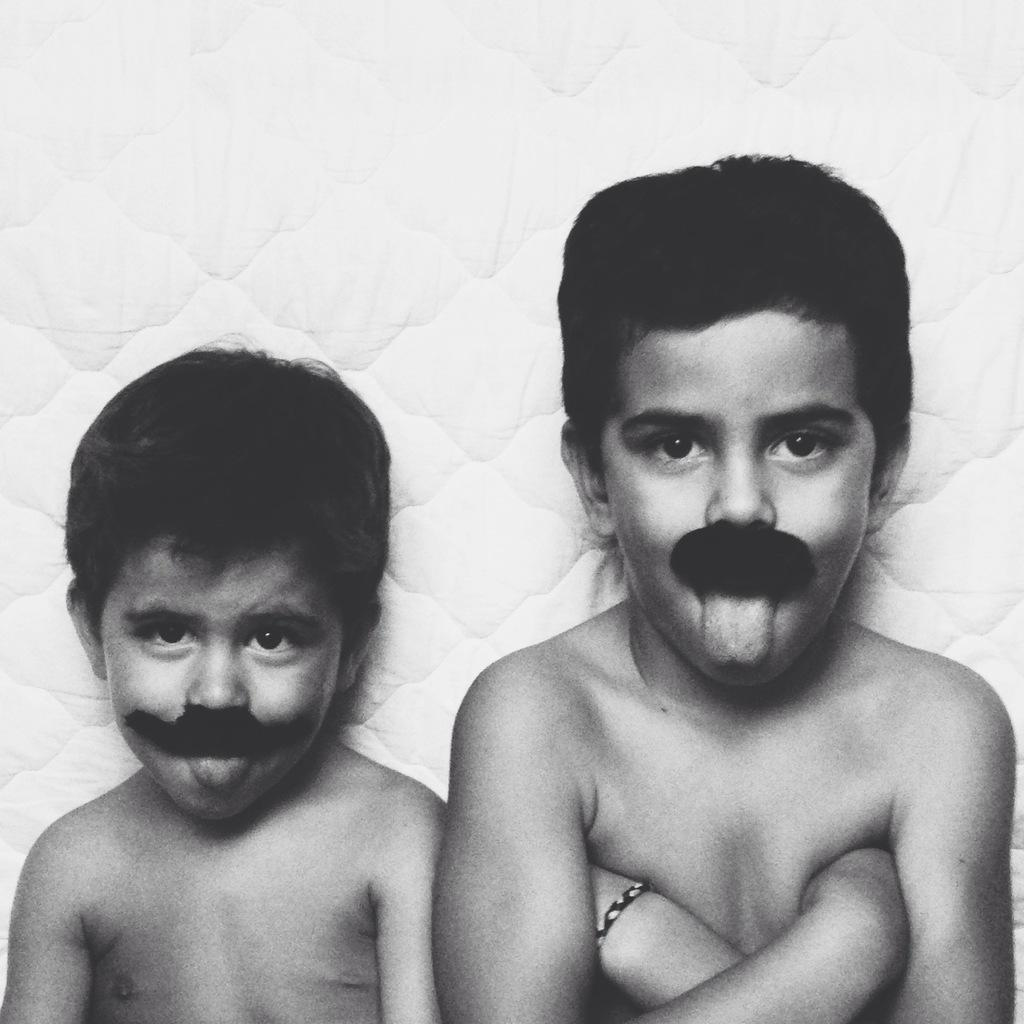How many children are present in the image? There are two small boys in the image. Where are the boys located in the image? The boys are in the center of the image. Reasoning: Let' Let's think step by step in order to produce the conversation. We start by identifying the main subjects in the image, which are the two small boys. Then, we describe their location within the image, noting that they are in the center. Each question is designed to elicit a specific detail about the image that is known from the provided facts. Absurd Question/Answer: What type of flower is the actor holding during the holiday scene in the image? There is no actor, flower, or holiday scene present in the image; it features two small boys in the center. What type of flower is the actor holding during the holiday scene in the image? There is no actor, flower, or holiday scene present in the image; it features two small boys in the center. 